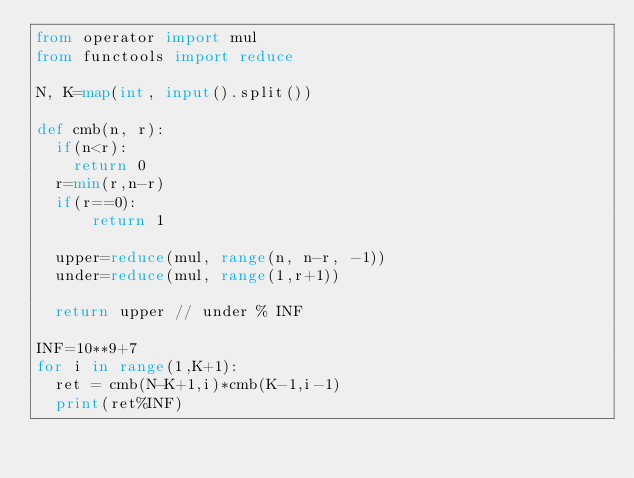<code> <loc_0><loc_0><loc_500><loc_500><_Python_>from operator import mul
from functools import reduce

N, K=map(int, input().split())

def cmb(n, r):
  if(n<r):
    return 0
  r=min(r,n-r)
  if(r==0):
      return 1  
  
  upper=reduce(mul, range(n, n-r, -1))
  under=reduce(mul, range(1,r+1))
    
  return upper // under % INF

INF=10**9+7
for i in range(1,K+1):
  ret = cmb(N-K+1,i)*cmb(K-1,i-1)
  print(ret%INF)
  </code> 